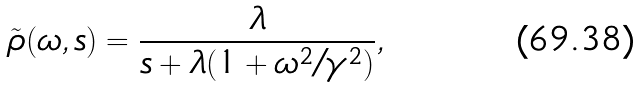<formula> <loc_0><loc_0><loc_500><loc_500>\tilde { \rho } ( \omega , s ) = \frac { \lambda } { s + \lambda ( 1 + \omega ^ { 2 } / \gamma ^ { 2 } ) } ,</formula> 